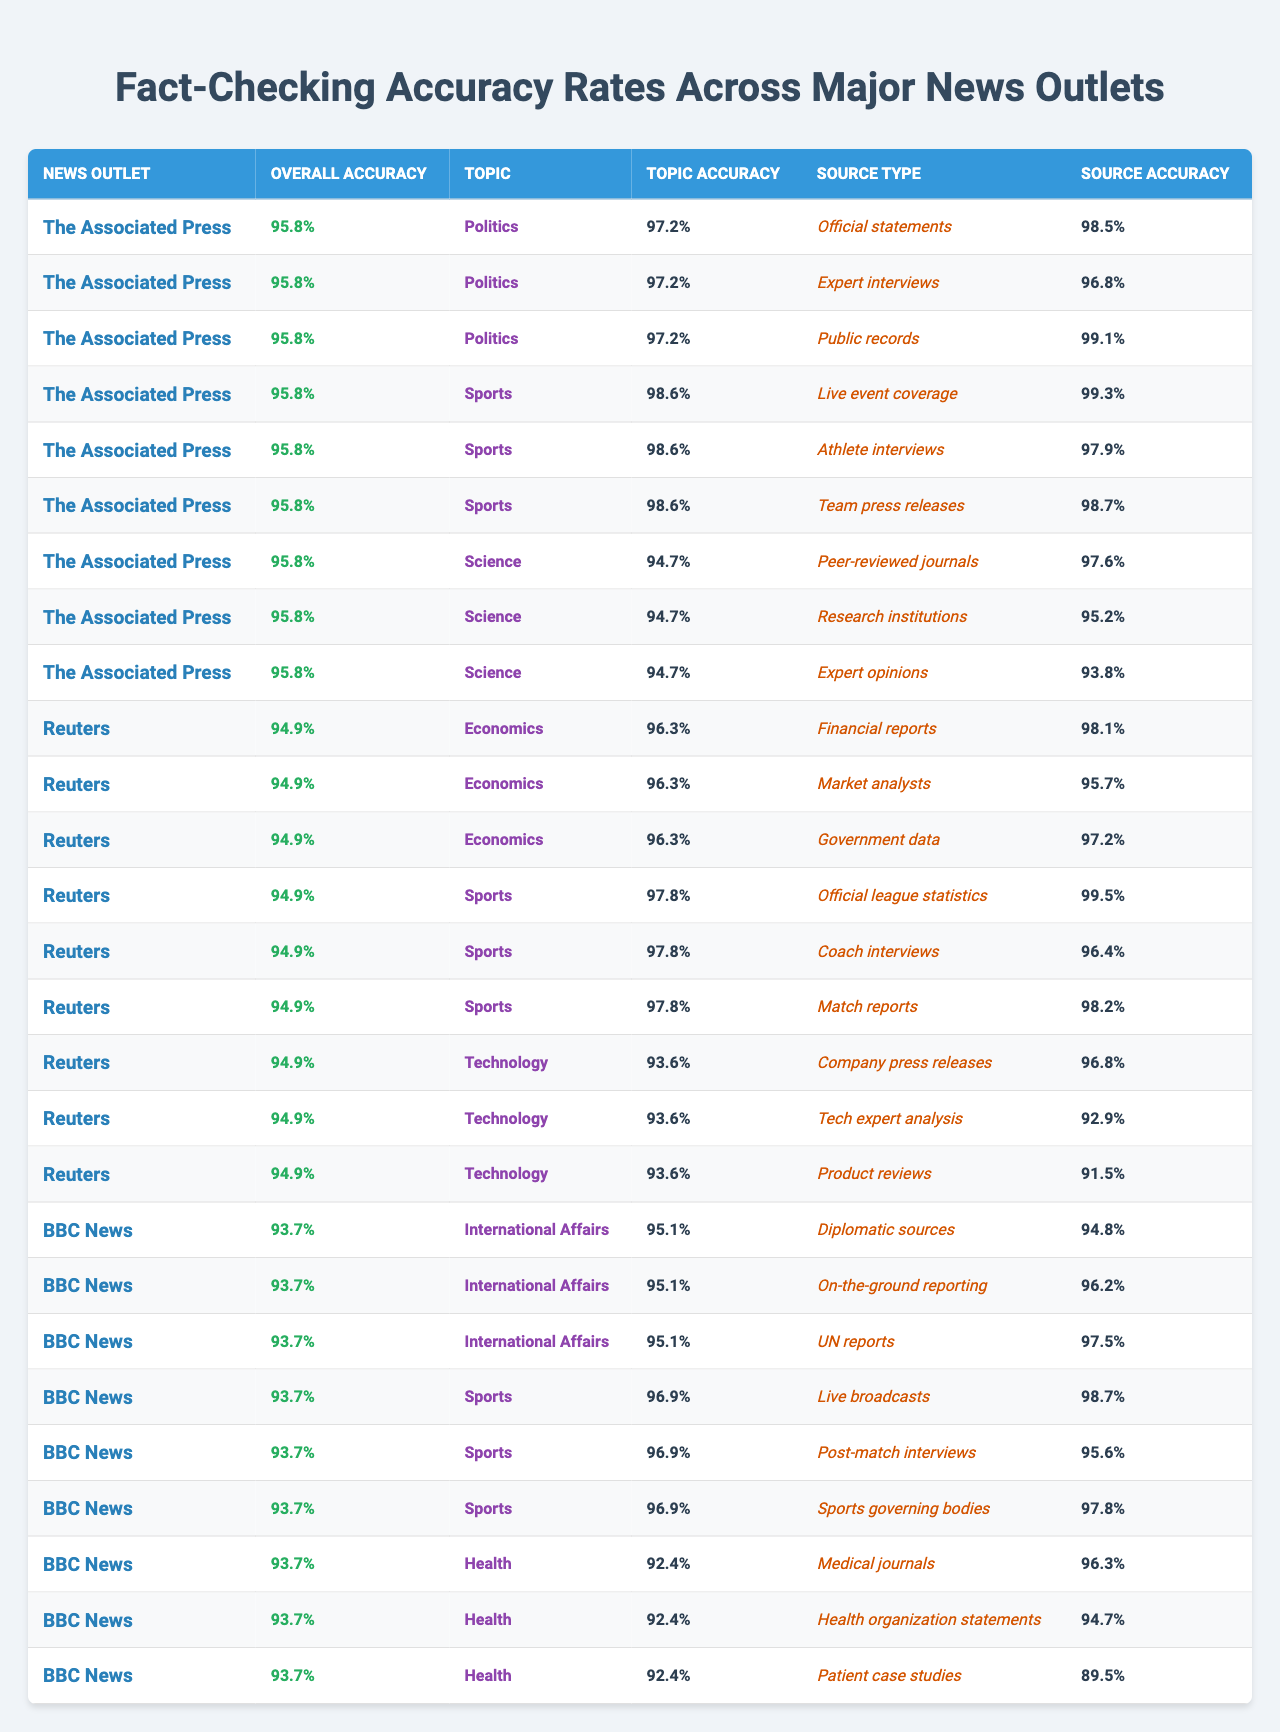What is the overall accuracy of The Associated Press? The table lists an overall accuracy for The Associated Press as 95.8%.
Answer: 95.8% Which news outlet has the highest topic accuracy in Sports? The Associated Press has a topic accuracy in Sports of 98.6%, which is higher than Reuters (97.8%) and BBC News (96.9%).
Answer: The Associated Press What is the source accuracy of expert interviews under the Politics category for The Associated Press? The source accuracy for expert interviews under Politics for The Associated Press is 96.8%.
Answer: 96.8% What is the average accuracy of source types for the Sports category from all news outlets? The source accuracies for Sports are: 99.3 (AP), 99.5 (Reuters), 98.7 (BBC). The average accuracy is (99.3 + 99.5 + 98.7) / 3 = 99.2%.
Answer: 99.2% Is the accuracy of government data under the Economics category for Reuters greater than 95%? The accuracy of government data for Reuters is 97.2%, which is greater than 95%.
Answer: Yes What is the overall accuracy of BBC News, and how does it compare to Reuters? BBC News has an overall accuracy of 93.7%, while Reuters has an overall accuracy of 94.9%. BBC News is lower than Reuters.
Answer: 93.7% Which source type has the lowest accuracy in the Technology category for Reuters? The source type with the lowest accuracy in the Technology category for Reuters is Product reviews, with an accuracy of 91.5%.
Answer: 91.5% For The Associated Press, how does the accuracy of public records in the Politics category compare to peer-reviewed journals in the Science category? Public records in Politics have an accuracy of 99.1%, while peer-reviewed journals in Science have an accuracy of 97.6%. Public records are more accurate than peer-reviewed journals.
Answer: Public records are more accurate What is the difference in accuracy between athlete interviews and team press releases under the Sports category for The Associated Press? Athlete interviews have an accuracy of 97.9% while team press releases have an accuracy of 98.7%. The difference is 98.7 - 97.9 = 0.8%.
Answer: 0.8% What is the overall accuracy of news outlets that cover Sports? The overall accuracy of the news outlets that cover Sports is: The Associated Press 95.8%, Reuters 94.9%, and BBC News 93.7%. The average overall accuracy is (95.8 + 94.9 + 93.7) / 3 = 94.8%.
Answer: 94.8% 